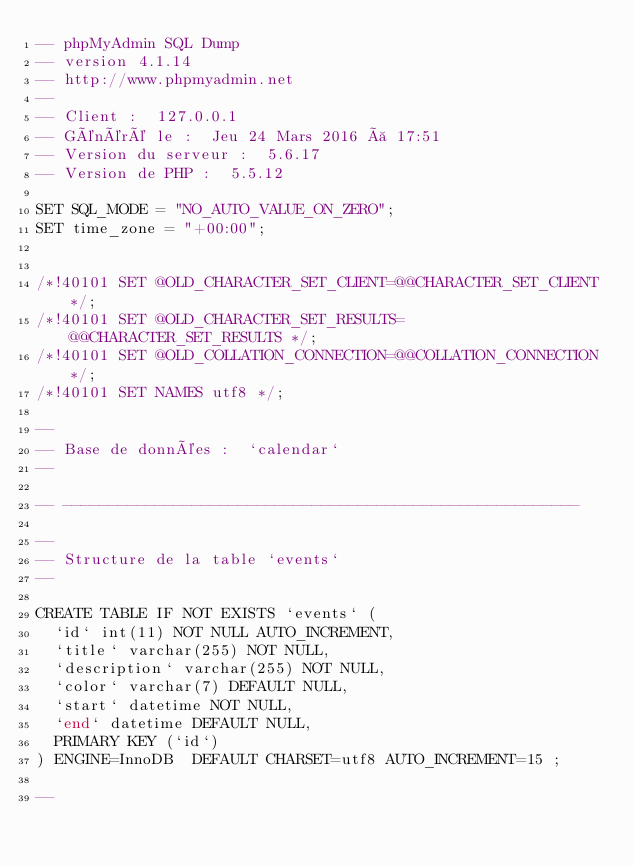<code> <loc_0><loc_0><loc_500><loc_500><_SQL_>-- phpMyAdmin SQL Dump
-- version 4.1.14
-- http://www.phpmyadmin.net
--
-- Client :  127.0.0.1
-- Généré le :  Jeu 24 Mars 2016 à 17:51
-- Version du serveur :  5.6.17
-- Version de PHP :  5.5.12

SET SQL_MODE = "NO_AUTO_VALUE_ON_ZERO";
SET time_zone = "+00:00";


/*!40101 SET @OLD_CHARACTER_SET_CLIENT=@@CHARACTER_SET_CLIENT */;
/*!40101 SET @OLD_CHARACTER_SET_RESULTS=@@CHARACTER_SET_RESULTS */;
/*!40101 SET @OLD_COLLATION_CONNECTION=@@COLLATION_CONNECTION */;
/*!40101 SET NAMES utf8 */;

--
-- Base de données :  `calendar`
--

-- --------------------------------------------------------

--
-- Structure de la table `events`
--

CREATE TABLE IF NOT EXISTS `events` (
  `id` int(11) NOT NULL AUTO_INCREMENT,
  `title` varchar(255) NOT NULL,
  `description` varchar(255) NOT NULL,
  `color` varchar(7) DEFAULT NULL,
  `start` datetime NOT NULL,
  `end` datetime DEFAULT NULL,
  PRIMARY KEY (`id`)
) ENGINE=InnoDB  DEFAULT CHARSET=utf8 AUTO_INCREMENT=15 ;

--</code> 